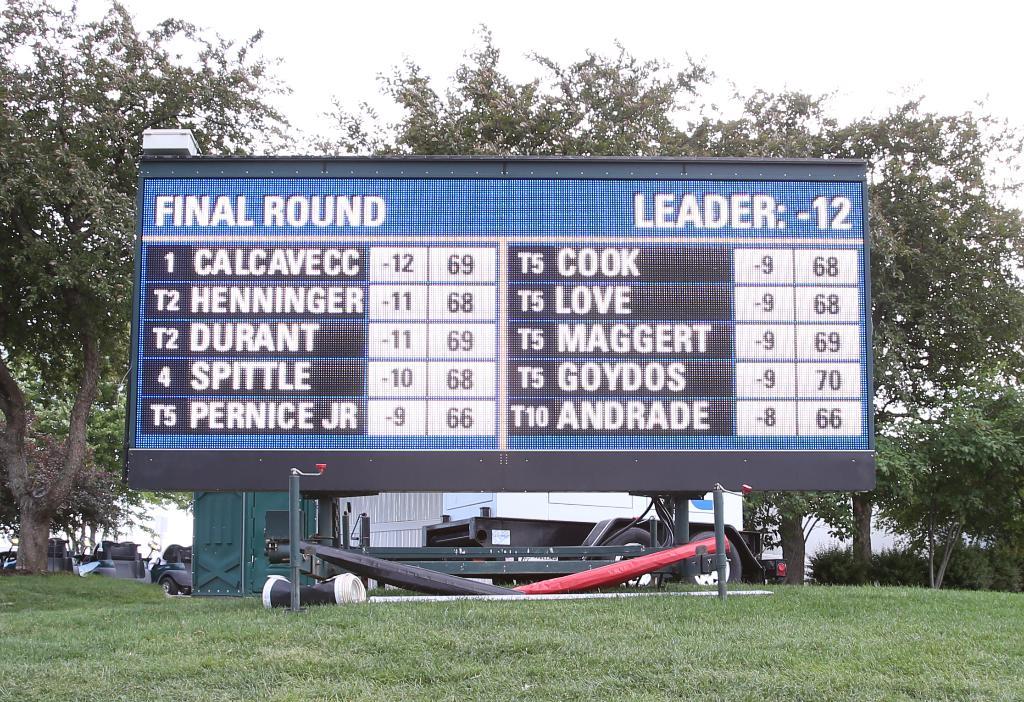Who is leading the game?
Offer a very short reply. Calcavecc. 